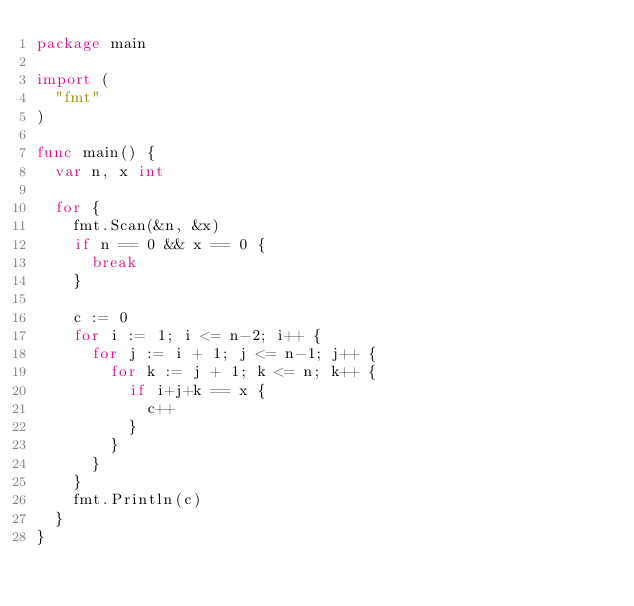<code> <loc_0><loc_0><loc_500><loc_500><_Go_>package main

import (
	"fmt"
)

func main() {
	var n, x int

	for {
		fmt.Scan(&n, &x)
		if n == 0 && x == 0 {
			break
		}

		c := 0
		for i := 1; i <= n-2; i++ {
			for j := i + 1; j <= n-1; j++ {
				for k := j + 1; k <= n; k++ {
					if i+j+k == x {
						c++
					}
				}
			}
		}
		fmt.Println(c)
	}
}

</code> 